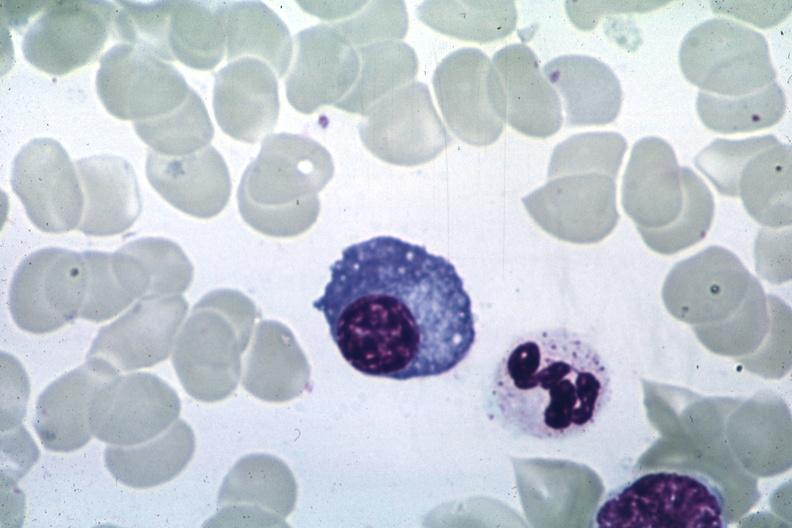s bone marrow present?
Answer the question using a single word or phrase. Yes 